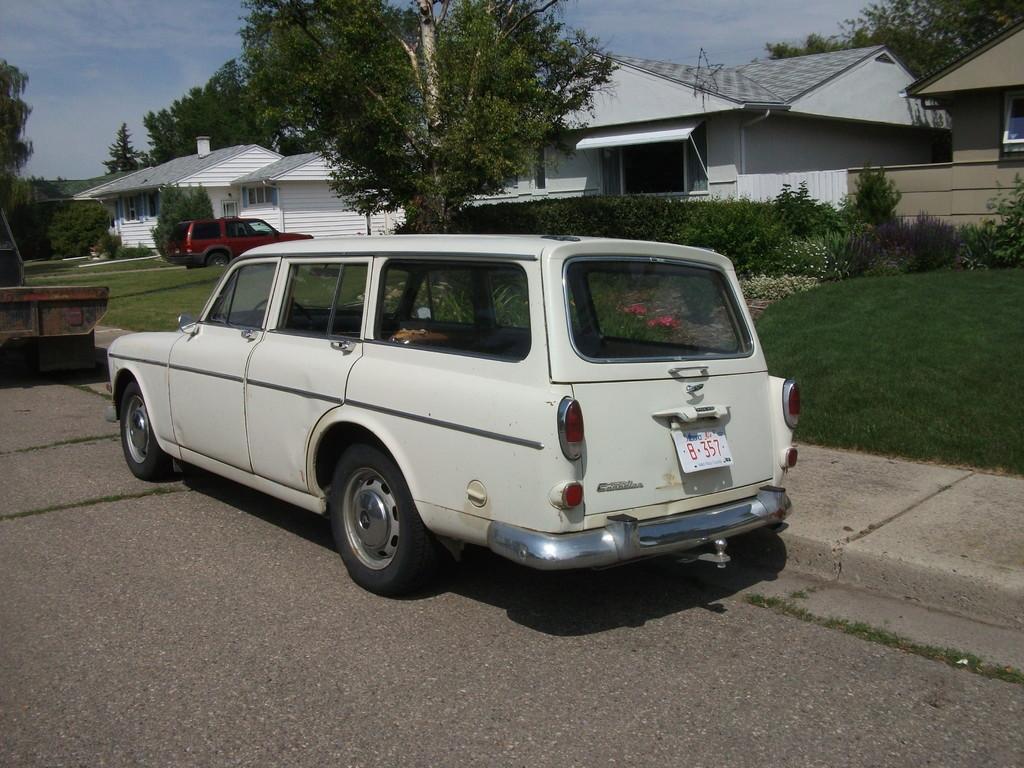Please provide a concise description of this image. In this image I can see the ground and a car which is white in color on the ground and I can see another vehicle in front of it. In the background I can see some grass, few red and cream colored flowers, few plants, few trees, few buildings, a red colored car and the sky. 